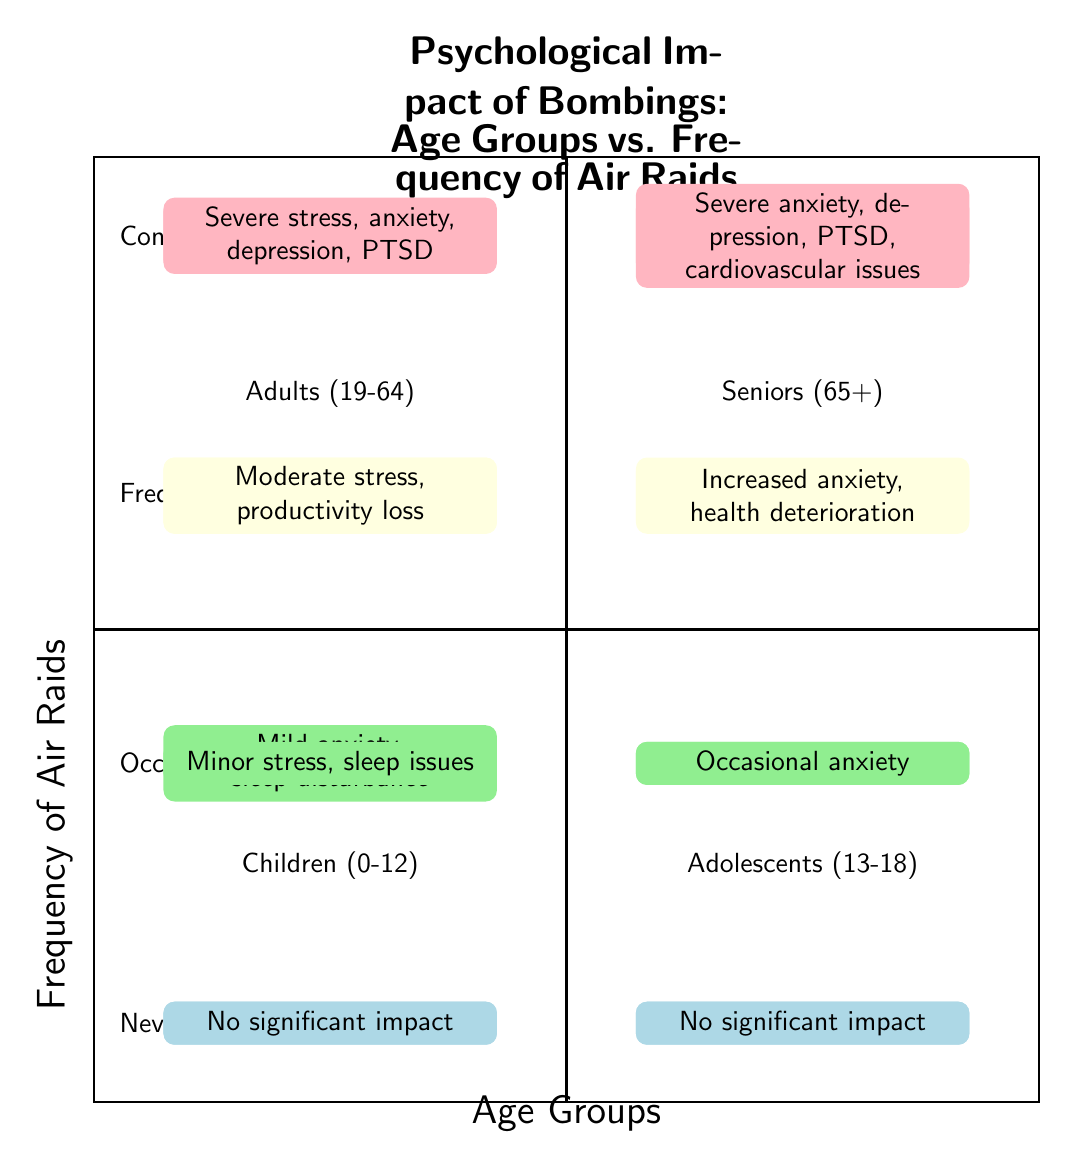What is the psychological impact on children aged 0-12 when air raids are occasional? The quadrant shows that for children aged 0-12, the impact of occasional air raids is "Mild anxiety, sleep disturbance". This information is directly represented in the section corresponding to the Children age group and Occasional frequency of air raids.
Answer: Mild anxiety, sleep disturbance What psychological impact is observed for seniors (65+) when air raids are frequent? According to the diagram, seniors (65+) experience "Increased anxiety, health deterioration" when air raids occur frequently. This is found in the quadrant where the Seniors age group intersects with Frequent frequency of air raids.
Answer: Increased anxiety, health deterioration Which age group shows severe anxiety and PTSD under constant air raid conditions? When considering constant air raid conditions, both children aged 0-12, adolescents aged 13-18, adults aged 19-64, and seniors aged 65+ experience severe anxiety and PTSD. However, this specific outcome is present across several age groups. Thus, each applicable age group's quadrant confirms this impact.
Answer: Children (0-12), Adolescents (13-18), Adults (19-64), Seniors (65+) What trend is seen regarding the psychological impact from 'Never' to 'Constant' for adults (19-64)? The trend for adults aged 19-64 progresses from "No significant impact" at Never frequency, to "Severe stress, anxiety, depression, PTSD" at Constant frequency, indicating an increasing severity of psychological impact as the frequency of air raids increases. This is determined by looking at the adult quadrant through all levels of air raid frequency.
Answer: Increasing severity How many age groups are represented in the diagram? The diagram features four distinct age groups: Children (0-12), Adolescents (13-18), Adults (19-64), and Seniors (65+). This count can be confirmed by simply identifying the labeled sections in the upper and lower segments of the diagram.
Answer: Four What is the psychological impact when adults (19-64) experience constant air raids? Adults aged 19-64 facing constant air raids suffer from "Severe stress, anxiety, depression, PTSD". This specific psychological impact appears in the quadrant designated for adults under the Constant air raid frequency.
Answer: Severe stress, anxiety, depression, PTSD For which age group is the psychological impact the least severe under occasional air raid conditions? The psychological impact is the least severe for Children (0-12) under occasional air raid conditions, as they experience "Mild anxiety, sleep disturbance" which is less severe compared to other groups. This can be determined by comparing impacts across different age groups at the occasional frequency.
Answer: Children (0-12) What is the common psychological impact for both adolescents (13-18) and seniors (65+) during frequent air raids? Both adolescents (13-18) and seniors (65+) experience "Severe anxiety" as a common psychological impact during frequent air raids. This can be derived from examining the respective quadrants for both age groups at the Frequent frequency level.
Answer: Severe anxiety 